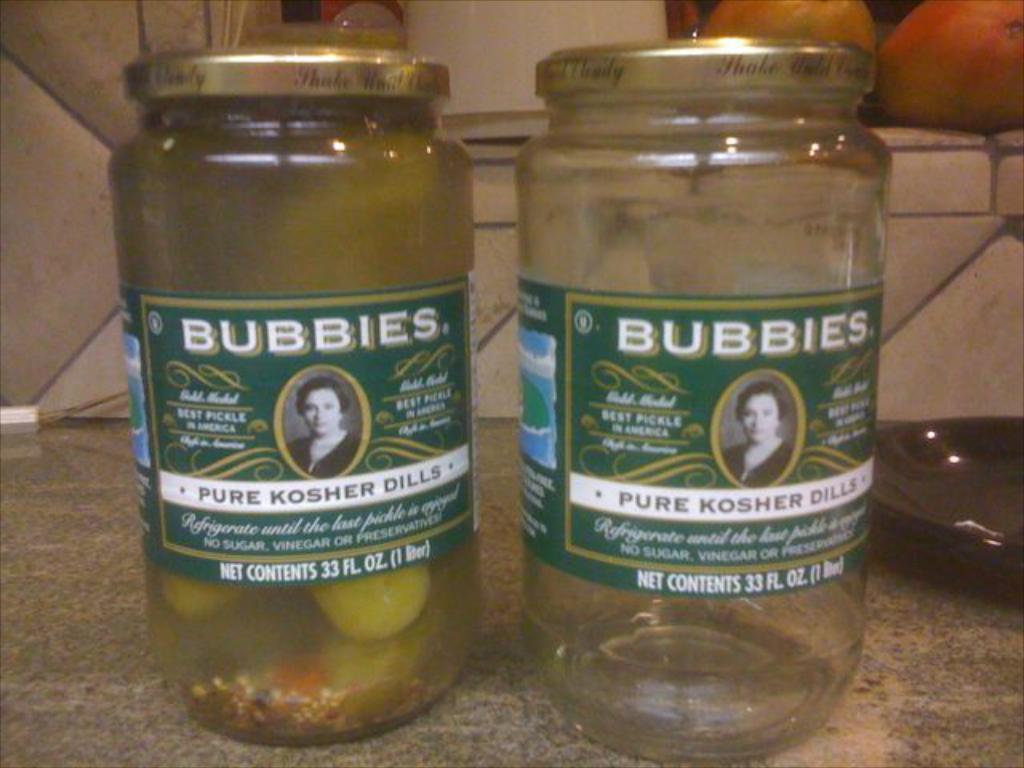Could you give a brief overview of what you see in this image? In this image we can see two glass bottles, one is empty and there are some items in other bottle and in the background of the image there is a wall, there are some fruits. 